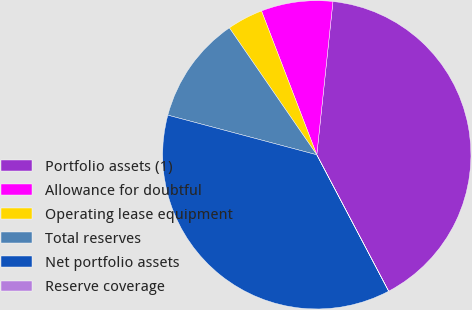Convert chart to OTSL. <chart><loc_0><loc_0><loc_500><loc_500><pie_chart><fcel>Portfolio assets (1)<fcel>Allowance for doubtful<fcel>Operating lease equipment<fcel>Total reserves<fcel>Net portfolio assets<fcel>Reserve coverage<nl><fcel>40.6%<fcel>7.51%<fcel>3.76%<fcel>11.26%<fcel>36.85%<fcel>0.01%<nl></chart> 